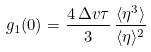<formula> <loc_0><loc_0><loc_500><loc_500>g _ { 1 } ( 0 ) = \frac { 4 \, \Delta v \tau } { 3 } \, \frac { \langle \eta ^ { 3 } \rangle } { \langle \eta \rangle ^ { 2 } }</formula> 